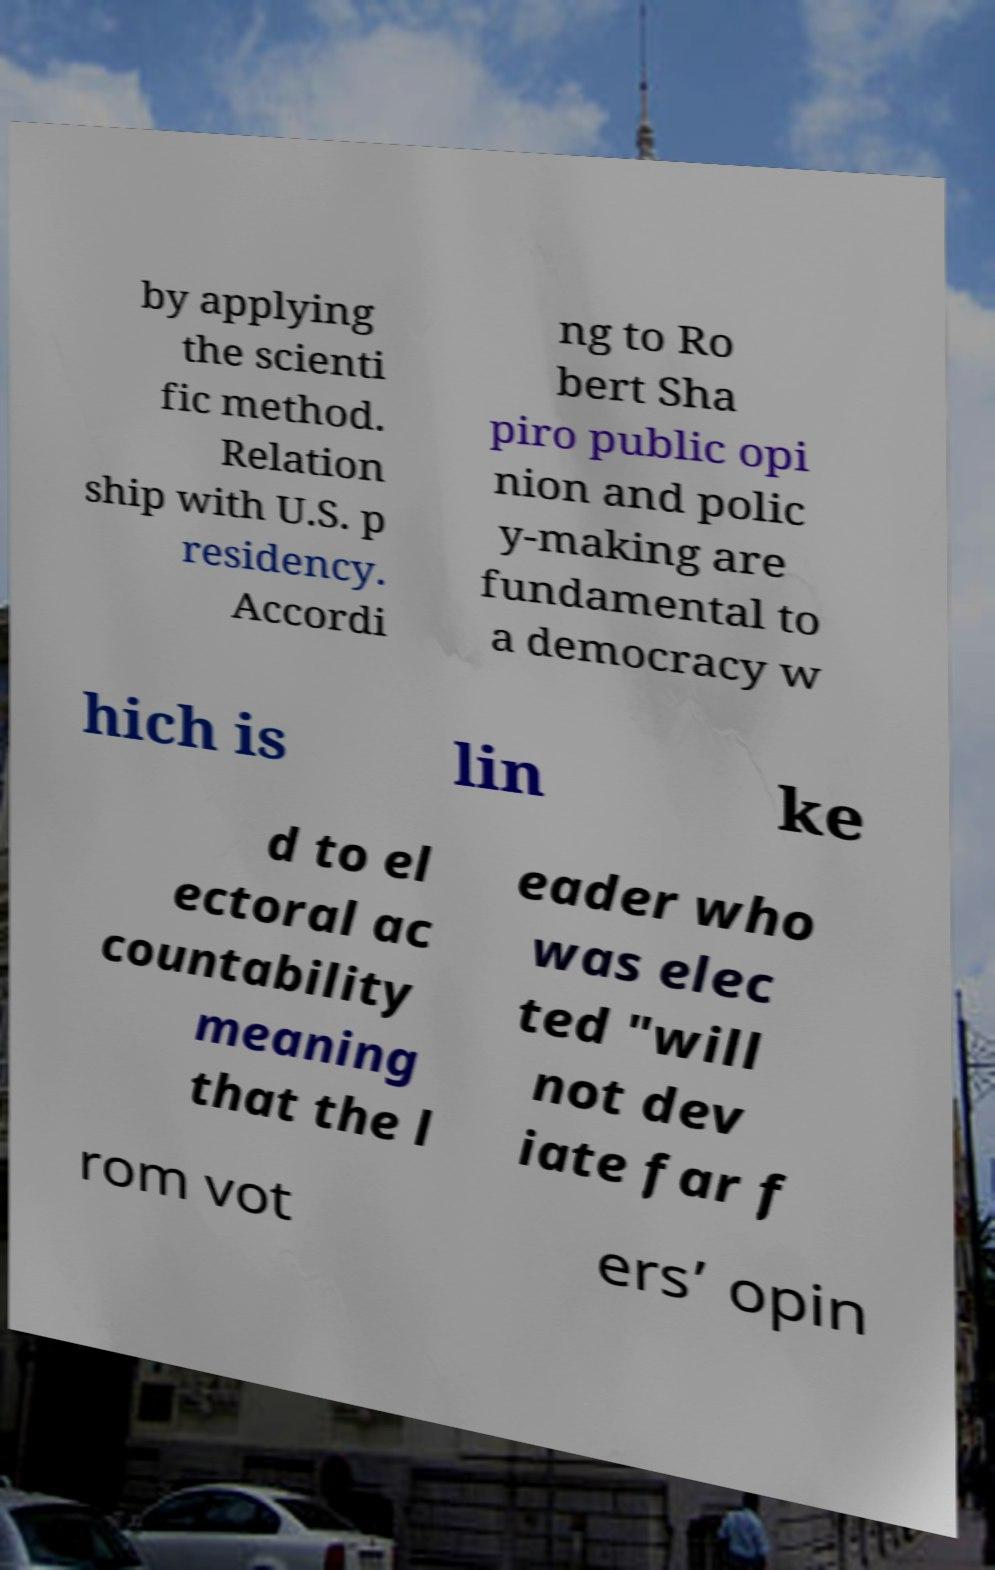For documentation purposes, I need the text within this image transcribed. Could you provide that? by applying the scienti fic method. Relation ship with U.S. p residency. Accordi ng to Ro bert Sha piro public opi nion and polic y-making are fundamental to a democracy w hich is lin ke d to el ectoral ac countability meaning that the l eader who was elec ted "will not dev iate far f rom vot ers’ opin 